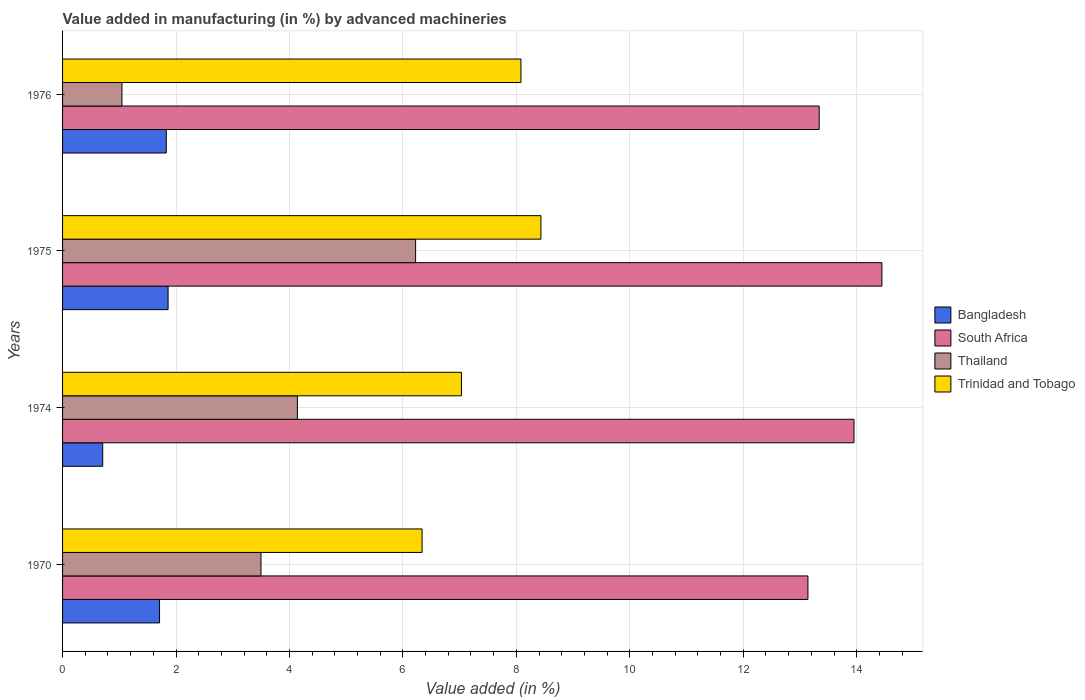Are the number of bars per tick equal to the number of legend labels?
Your response must be concise. Yes. How many bars are there on the 4th tick from the top?
Offer a terse response. 4. What is the label of the 1st group of bars from the top?
Make the answer very short. 1976. What is the percentage of value added in manufacturing by advanced machineries in Thailand in 1975?
Provide a succinct answer. 6.22. Across all years, what is the maximum percentage of value added in manufacturing by advanced machineries in Trinidad and Tobago?
Your answer should be very brief. 8.43. Across all years, what is the minimum percentage of value added in manufacturing by advanced machineries in South Africa?
Offer a very short reply. 13.14. In which year was the percentage of value added in manufacturing by advanced machineries in Thailand maximum?
Offer a terse response. 1975. In which year was the percentage of value added in manufacturing by advanced machineries in Thailand minimum?
Offer a very short reply. 1976. What is the total percentage of value added in manufacturing by advanced machineries in Bangladesh in the graph?
Provide a succinct answer. 6.11. What is the difference between the percentage of value added in manufacturing by advanced machineries in Thailand in 1974 and that in 1976?
Keep it short and to the point. 3.09. What is the difference between the percentage of value added in manufacturing by advanced machineries in Trinidad and Tobago in 1975 and the percentage of value added in manufacturing by advanced machineries in South Africa in 1974?
Offer a very short reply. -5.52. What is the average percentage of value added in manufacturing by advanced machineries in South Africa per year?
Offer a terse response. 13.72. In the year 1976, what is the difference between the percentage of value added in manufacturing by advanced machineries in South Africa and percentage of value added in manufacturing by advanced machineries in Bangladesh?
Your answer should be compact. 11.51. In how many years, is the percentage of value added in manufacturing by advanced machineries in Thailand greater than 11.6 %?
Your answer should be compact. 0. What is the ratio of the percentage of value added in manufacturing by advanced machineries in South Africa in 1975 to that in 1976?
Offer a very short reply. 1.08. Is the percentage of value added in manufacturing by advanced machineries in South Africa in 1975 less than that in 1976?
Give a very brief answer. No. What is the difference between the highest and the second highest percentage of value added in manufacturing by advanced machineries in Bangladesh?
Ensure brevity in your answer.  0.03. What is the difference between the highest and the lowest percentage of value added in manufacturing by advanced machineries in Trinidad and Tobago?
Offer a very short reply. 2.1. In how many years, is the percentage of value added in manufacturing by advanced machineries in South Africa greater than the average percentage of value added in manufacturing by advanced machineries in South Africa taken over all years?
Keep it short and to the point. 2. Is the sum of the percentage of value added in manufacturing by advanced machineries in Bangladesh in 1970 and 1974 greater than the maximum percentage of value added in manufacturing by advanced machineries in South Africa across all years?
Provide a short and direct response. No. Is it the case that in every year, the sum of the percentage of value added in manufacturing by advanced machineries in South Africa and percentage of value added in manufacturing by advanced machineries in Thailand is greater than the sum of percentage of value added in manufacturing by advanced machineries in Bangladesh and percentage of value added in manufacturing by advanced machineries in Trinidad and Tobago?
Keep it short and to the point. Yes. What does the 2nd bar from the top in 1970 represents?
Provide a short and direct response. Thailand. What does the 4th bar from the bottom in 1974 represents?
Ensure brevity in your answer.  Trinidad and Tobago. What is the difference between two consecutive major ticks on the X-axis?
Give a very brief answer. 2. Where does the legend appear in the graph?
Your response must be concise. Center right. What is the title of the graph?
Provide a short and direct response. Value added in manufacturing (in %) by advanced machineries. What is the label or title of the X-axis?
Your response must be concise. Value added (in %). What is the label or title of the Y-axis?
Ensure brevity in your answer.  Years. What is the Value added (in %) of Bangladesh in 1970?
Your response must be concise. 1.71. What is the Value added (in %) of South Africa in 1970?
Make the answer very short. 13.14. What is the Value added (in %) in Thailand in 1970?
Make the answer very short. 3.5. What is the Value added (in %) in Trinidad and Tobago in 1970?
Your answer should be compact. 6.34. What is the Value added (in %) in Bangladesh in 1974?
Keep it short and to the point. 0.71. What is the Value added (in %) in South Africa in 1974?
Offer a terse response. 13.95. What is the Value added (in %) in Thailand in 1974?
Make the answer very short. 4.14. What is the Value added (in %) in Trinidad and Tobago in 1974?
Provide a succinct answer. 7.03. What is the Value added (in %) of Bangladesh in 1975?
Provide a succinct answer. 1.86. What is the Value added (in %) of South Africa in 1975?
Provide a short and direct response. 14.44. What is the Value added (in %) in Thailand in 1975?
Your answer should be very brief. 6.22. What is the Value added (in %) in Trinidad and Tobago in 1975?
Make the answer very short. 8.43. What is the Value added (in %) in Bangladesh in 1976?
Your answer should be compact. 1.83. What is the Value added (in %) of South Africa in 1976?
Your answer should be very brief. 13.34. What is the Value added (in %) in Thailand in 1976?
Provide a short and direct response. 1.05. What is the Value added (in %) in Trinidad and Tobago in 1976?
Give a very brief answer. 8.08. Across all years, what is the maximum Value added (in %) in Bangladesh?
Your answer should be compact. 1.86. Across all years, what is the maximum Value added (in %) of South Africa?
Your answer should be compact. 14.44. Across all years, what is the maximum Value added (in %) in Thailand?
Provide a short and direct response. 6.22. Across all years, what is the maximum Value added (in %) in Trinidad and Tobago?
Your answer should be very brief. 8.43. Across all years, what is the minimum Value added (in %) of Bangladesh?
Provide a succinct answer. 0.71. Across all years, what is the minimum Value added (in %) of South Africa?
Offer a very short reply. 13.14. Across all years, what is the minimum Value added (in %) in Thailand?
Your response must be concise. 1.05. Across all years, what is the minimum Value added (in %) in Trinidad and Tobago?
Keep it short and to the point. 6.34. What is the total Value added (in %) of Bangladesh in the graph?
Your answer should be very brief. 6.11. What is the total Value added (in %) of South Africa in the graph?
Your answer should be compact. 54.88. What is the total Value added (in %) in Thailand in the graph?
Your response must be concise. 14.91. What is the total Value added (in %) of Trinidad and Tobago in the graph?
Provide a succinct answer. 29.88. What is the difference between the Value added (in %) in South Africa in 1970 and that in 1974?
Keep it short and to the point. -0.81. What is the difference between the Value added (in %) of Thailand in 1970 and that in 1974?
Give a very brief answer. -0.64. What is the difference between the Value added (in %) of Trinidad and Tobago in 1970 and that in 1974?
Provide a short and direct response. -0.69. What is the difference between the Value added (in %) in Bangladesh in 1970 and that in 1975?
Provide a short and direct response. -0.15. What is the difference between the Value added (in %) of South Africa in 1970 and that in 1975?
Offer a terse response. -1.3. What is the difference between the Value added (in %) in Thailand in 1970 and that in 1975?
Your answer should be compact. -2.73. What is the difference between the Value added (in %) of Trinidad and Tobago in 1970 and that in 1975?
Offer a terse response. -2.1. What is the difference between the Value added (in %) in Bangladesh in 1970 and that in 1976?
Your answer should be compact. -0.12. What is the difference between the Value added (in %) in South Africa in 1970 and that in 1976?
Your response must be concise. -0.2. What is the difference between the Value added (in %) in Thailand in 1970 and that in 1976?
Offer a very short reply. 2.45. What is the difference between the Value added (in %) of Trinidad and Tobago in 1970 and that in 1976?
Give a very brief answer. -1.74. What is the difference between the Value added (in %) in Bangladesh in 1974 and that in 1975?
Ensure brevity in your answer.  -1.15. What is the difference between the Value added (in %) in South Africa in 1974 and that in 1975?
Keep it short and to the point. -0.49. What is the difference between the Value added (in %) of Thailand in 1974 and that in 1975?
Give a very brief answer. -2.08. What is the difference between the Value added (in %) in Trinidad and Tobago in 1974 and that in 1975?
Offer a very short reply. -1.4. What is the difference between the Value added (in %) in Bangladesh in 1974 and that in 1976?
Your response must be concise. -1.12. What is the difference between the Value added (in %) of South Africa in 1974 and that in 1976?
Make the answer very short. 0.61. What is the difference between the Value added (in %) in Thailand in 1974 and that in 1976?
Make the answer very short. 3.09. What is the difference between the Value added (in %) of Trinidad and Tobago in 1974 and that in 1976?
Offer a very short reply. -1.05. What is the difference between the Value added (in %) of Bangladesh in 1975 and that in 1976?
Make the answer very short. 0.03. What is the difference between the Value added (in %) of South Africa in 1975 and that in 1976?
Offer a terse response. 1.11. What is the difference between the Value added (in %) of Thailand in 1975 and that in 1976?
Make the answer very short. 5.18. What is the difference between the Value added (in %) in Trinidad and Tobago in 1975 and that in 1976?
Ensure brevity in your answer.  0.35. What is the difference between the Value added (in %) in Bangladesh in 1970 and the Value added (in %) in South Africa in 1974?
Offer a terse response. -12.24. What is the difference between the Value added (in %) in Bangladesh in 1970 and the Value added (in %) in Thailand in 1974?
Offer a terse response. -2.43. What is the difference between the Value added (in %) in Bangladesh in 1970 and the Value added (in %) in Trinidad and Tobago in 1974?
Your answer should be compact. -5.32. What is the difference between the Value added (in %) in South Africa in 1970 and the Value added (in %) in Thailand in 1974?
Offer a very short reply. 9. What is the difference between the Value added (in %) of South Africa in 1970 and the Value added (in %) of Trinidad and Tobago in 1974?
Your answer should be very brief. 6.11. What is the difference between the Value added (in %) of Thailand in 1970 and the Value added (in %) of Trinidad and Tobago in 1974?
Give a very brief answer. -3.53. What is the difference between the Value added (in %) of Bangladesh in 1970 and the Value added (in %) of South Africa in 1975?
Keep it short and to the point. -12.73. What is the difference between the Value added (in %) in Bangladesh in 1970 and the Value added (in %) in Thailand in 1975?
Give a very brief answer. -4.51. What is the difference between the Value added (in %) in Bangladesh in 1970 and the Value added (in %) in Trinidad and Tobago in 1975?
Ensure brevity in your answer.  -6.72. What is the difference between the Value added (in %) in South Africa in 1970 and the Value added (in %) in Thailand in 1975?
Offer a very short reply. 6.92. What is the difference between the Value added (in %) of South Africa in 1970 and the Value added (in %) of Trinidad and Tobago in 1975?
Offer a terse response. 4.71. What is the difference between the Value added (in %) of Thailand in 1970 and the Value added (in %) of Trinidad and Tobago in 1975?
Your response must be concise. -4.94. What is the difference between the Value added (in %) in Bangladesh in 1970 and the Value added (in %) in South Africa in 1976?
Your answer should be compact. -11.63. What is the difference between the Value added (in %) of Bangladesh in 1970 and the Value added (in %) of Thailand in 1976?
Ensure brevity in your answer.  0.66. What is the difference between the Value added (in %) in Bangladesh in 1970 and the Value added (in %) in Trinidad and Tobago in 1976?
Give a very brief answer. -6.37. What is the difference between the Value added (in %) in South Africa in 1970 and the Value added (in %) in Thailand in 1976?
Your response must be concise. 12.09. What is the difference between the Value added (in %) of South Africa in 1970 and the Value added (in %) of Trinidad and Tobago in 1976?
Ensure brevity in your answer.  5.06. What is the difference between the Value added (in %) of Thailand in 1970 and the Value added (in %) of Trinidad and Tobago in 1976?
Keep it short and to the point. -4.58. What is the difference between the Value added (in %) of Bangladesh in 1974 and the Value added (in %) of South Africa in 1975?
Your response must be concise. -13.74. What is the difference between the Value added (in %) of Bangladesh in 1974 and the Value added (in %) of Thailand in 1975?
Provide a succinct answer. -5.52. What is the difference between the Value added (in %) in Bangladesh in 1974 and the Value added (in %) in Trinidad and Tobago in 1975?
Ensure brevity in your answer.  -7.73. What is the difference between the Value added (in %) of South Africa in 1974 and the Value added (in %) of Thailand in 1975?
Offer a very short reply. 7.73. What is the difference between the Value added (in %) of South Africa in 1974 and the Value added (in %) of Trinidad and Tobago in 1975?
Make the answer very short. 5.52. What is the difference between the Value added (in %) of Thailand in 1974 and the Value added (in %) of Trinidad and Tobago in 1975?
Offer a terse response. -4.29. What is the difference between the Value added (in %) of Bangladesh in 1974 and the Value added (in %) of South Africa in 1976?
Give a very brief answer. -12.63. What is the difference between the Value added (in %) in Bangladesh in 1974 and the Value added (in %) in Thailand in 1976?
Give a very brief answer. -0.34. What is the difference between the Value added (in %) of Bangladesh in 1974 and the Value added (in %) of Trinidad and Tobago in 1976?
Provide a short and direct response. -7.37. What is the difference between the Value added (in %) of South Africa in 1974 and the Value added (in %) of Thailand in 1976?
Your answer should be very brief. 12.91. What is the difference between the Value added (in %) of South Africa in 1974 and the Value added (in %) of Trinidad and Tobago in 1976?
Your response must be concise. 5.87. What is the difference between the Value added (in %) of Thailand in 1974 and the Value added (in %) of Trinidad and Tobago in 1976?
Provide a succinct answer. -3.94. What is the difference between the Value added (in %) in Bangladesh in 1975 and the Value added (in %) in South Africa in 1976?
Ensure brevity in your answer.  -11.48. What is the difference between the Value added (in %) of Bangladesh in 1975 and the Value added (in %) of Thailand in 1976?
Your response must be concise. 0.81. What is the difference between the Value added (in %) in Bangladesh in 1975 and the Value added (in %) in Trinidad and Tobago in 1976?
Provide a short and direct response. -6.22. What is the difference between the Value added (in %) of South Africa in 1975 and the Value added (in %) of Thailand in 1976?
Keep it short and to the point. 13.4. What is the difference between the Value added (in %) of South Africa in 1975 and the Value added (in %) of Trinidad and Tobago in 1976?
Your answer should be compact. 6.36. What is the difference between the Value added (in %) of Thailand in 1975 and the Value added (in %) of Trinidad and Tobago in 1976?
Give a very brief answer. -1.86. What is the average Value added (in %) of Bangladesh per year?
Your answer should be very brief. 1.53. What is the average Value added (in %) of South Africa per year?
Provide a short and direct response. 13.72. What is the average Value added (in %) in Thailand per year?
Ensure brevity in your answer.  3.73. What is the average Value added (in %) of Trinidad and Tobago per year?
Ensure brevity in your answer.  7.47. In the year 1970, what is the difference between the Value added (in %) of Bangladesh and Value added (in %) of South Africa?
Provide a short and direct response. -11.43. In the year 1970, what is the difference between the Value added (in %) in Bangladesh and Value added (in %) in Thailand?
Your response must be concise. -1.79. In the year 1970, what is the difference between the Value added (in %) in Bangladesh and Value added (in %) in Trinidad and Tobago?
Offer a very short reply. -4.63. In the year 1970, what is the difference between the Value added (in %) of South Africa and Value added (in %) of Thailand?
Your answer should be compact. 9.64. In the year 1970, what is the difference between the Value added (in %) in South Africa and Value added (in %) in Trinidad and Tobago?
Offer a very short reply. 6.8. In the year 1970, what is the difference between the Value added (in %) of Thailand and Value added (in %) of Trinidad and Tobago?
Keep it short and to the point. -2.84. In the year 1974, what is the difference between the Value added (in %) of Bangladesh and Value added (in %) of South Africa?
Give a very brief answer. -13.24. In the year 1974, what is the difference between the Value added (in %) in Bangladesh and Value added (in %) in Thailand?
Make the answer very short. -3.43. In the year 1974, what is the difference between the Value added (in %) in Bangladesh and Value added (in %) in Trinidad and Tobago?
Offer a very short reply. -6.32. In the year 1974, what is the difference between the Value added (in %) of South Africa and Value added (in %) of Thailand?
Offer a very short reply. 9.81. In the year 1974, what is the difference between the Value added (in %) in South Africa and Value added (in %) in Trinidad and Tobago?
Keep it short and to the point. 6.92. In the year 1974, what is the difference between the Value added (in %) in Thailand and Value added (in %) in Trinidad and Tobago?
Your response must be concise. -2.89. In the year 1975, what is the difference between the Value added (in %) of Bangladesh and Value added (in %) of South Africa?
Your answer should be compact. -12.58. In the year 1975, what is the difference between the Value added (in %) in Bangladesh and Value added (in %) in Thailand?
Offer a very short reply. -4.36. In the year 1975, what is the difference between the Value added (in %) of Bangladesh and Value added (in %) of Trinidad and Tobago?
Ensure brevity in your answer.  -6.57. In the year 1975, what is the difference between the Value added (in %) of South Africa and Value added (in %) of Thailand?
Provide a short and direct response. 8.22. In the year 1975, what is the difference between the Value added (in %) of South Africa and Value added (in %) of Trinidad and Tobago?
Make the answer very short. 6.01. In the year 1975, what is the difference between the Value added (in %) of Thailand and Value added (in %) of Trinidad and Tobago?
Provide a succinct answer. -2.21. In the year 1976, what is the difference between the Value added (in %) in Bangladesh and Value added (in %) in South Africa?
Give a very brief answer. -11.51. In the year 1976, what is the difference between the Value added (in %) of Bangladesh and Value added (in %) of Thailand?
Offer a terse response. 0.78. In the year 1976, what is the difference between the Value added (in %) of Bangladesh and Value added (in %) of Trinidad and Tobago?
Make the answer very short. -6.25. In the year 1976, what is the difference between the Value added (in %) of South Africa and Value added (in %) of Thailand?
Give a very brief answer. 12.29. In the year 1976, what is the difference between the Value added (in %) of South Africa and Value added (in %) of Trinidad and Tobago?
Give a very brief answer. 5.26. In the year 1976, what is the difference between the Value added (in %) in Thailand and Value added (in %) in Trinidad and Tobago?
Provide a short and direct response. -7.03. What is the ratio of the Value added (in %) of Bangladesh in 1970 to that in 1974?
Your answer should be very brief. 2.42. What is the ratio of the Value added (in %) of South Africa in 1970 to that in 1974?
Give a very brief answer. 0.94. What is the ratio of the Value added (in %) in Thailand in 1970 to that in 1974?
Provide a succinct answer. 0.84. What is the ratio of the Value added (in %) of Trinidad and Tobago in 1970 to that in 1974?
Your response must be concise. 0.9. What is the ratio of the Value added (in %) in Bangladesh in 1970 to that in 1975?
Offer a terse response. 0.92. What is the ratio of the Value added (in %) of South Africa in 1970 to that in 1975?
Your response must be concise. 0.91. What is the ratio of the Value added (in %) in Thailand in 1970 to that in 1975?
Make the answer very short. 0.56. What is the ratio of the Value added (in %) in Trinidad and Tobago in 1970 to that in 1975?
Keep it short and to the point. 0.75. What is the ratio of the Value added (in %) in Bangladesh in 1970 to that in 1976?
Your response must be concise. 0.94. What is the ratio of the Value added (in %) in South Africa in 1970 to that in 1976?
Provide a short and direct response. 0.99. What is the ratio of the Value added (in %) in Thailand in 1970 to that in 1976?
Give a very brief answer. 3.34. What is the ratio of the Value added (in %) in Trinidad and Tobago in 1970 to that in 1976?
Offer a very short reply. 0.78. What is the ratio of the Value added (in %) of Bangladesh in 1974 to that in 1975?
Offer a very short reply. 0.38. What is the ratio of the Value added (in %) in South Africa in 1974 to that in 1975?
Provide a short and direct response. 0.97. What is the ratio of the Value added (in %) of Thailand in 1974 to that in 1975?
Make the answer very short. 0.67. What is the ratio of the Value added (in %) of Trinidad and Tobago in 1974 to that in 1975?
Keep it short and to the point. 0.83. What is the ratio of the Value added (in %) of Bangladesh in 1974 to that in 1976?
Provide a succinct answer. 0.39. What is the ratio of the Value added (in %) of South Africa in 1974 to that in 1976?
Offer a terse response. 1.05. What is the ratio of the Value added (in %) of Thailand in 1974 to that in 1976?
Your answer should be compact. 3.95. What is the ratio of the Value added (in %) in Trinidad and Tobago in 1974 to that in 1976?
Your answer should be very brief. 0.87. What is the ratio of the Value added (in %) in Bangladesh in 1975 to that in 1976?
Make the answer very short. 1.02. What is the ratio of the Value added (in %) of South Africa in 1975 to that in 1976?
Keep it short and to the point. 1.08. What is the ratio of the Value added (in %) of Thailand in 1975 to that in 1976?
Provide a short and direct response. 5.94. What is the ratio of the Value added (in %) of Trinidad and Tobago in 1975 to that in 1976?
Offer a terse response. 1.04. What is the difference between the highest and the second highest Value added (in %) of Bangladesh?
Provide a succinct answer. 0.03. What is the difference between the highest and the second highest Value added (in %) of South Africa?
Provide a succinct answer. 0.49. What is the difference between the highest and the second highest Value added (in %) of Thailand?
Keep it short and to the point. 2.08. What is the difference between the highest and the second highest Value added (in %) in Trinidad and Tobago?
Offer a very short reply. 0.35. What is the difference between the highest and the lowest Value added (in %) of Bangladesh?
Provide a short and direct response. 1.15. What is the difference between the highest and the lowest Value added (in %) in South Africa?
Make the answer very short. 1.3. What is the difference between the highest and the lowest Value added (in %) of Thailand?
Your response must be concise. 5.18. What is the difference between the highest and the lowest Value added (in %) in Trinidad and Tobago?
Keep it short and to the point. 2.1. 